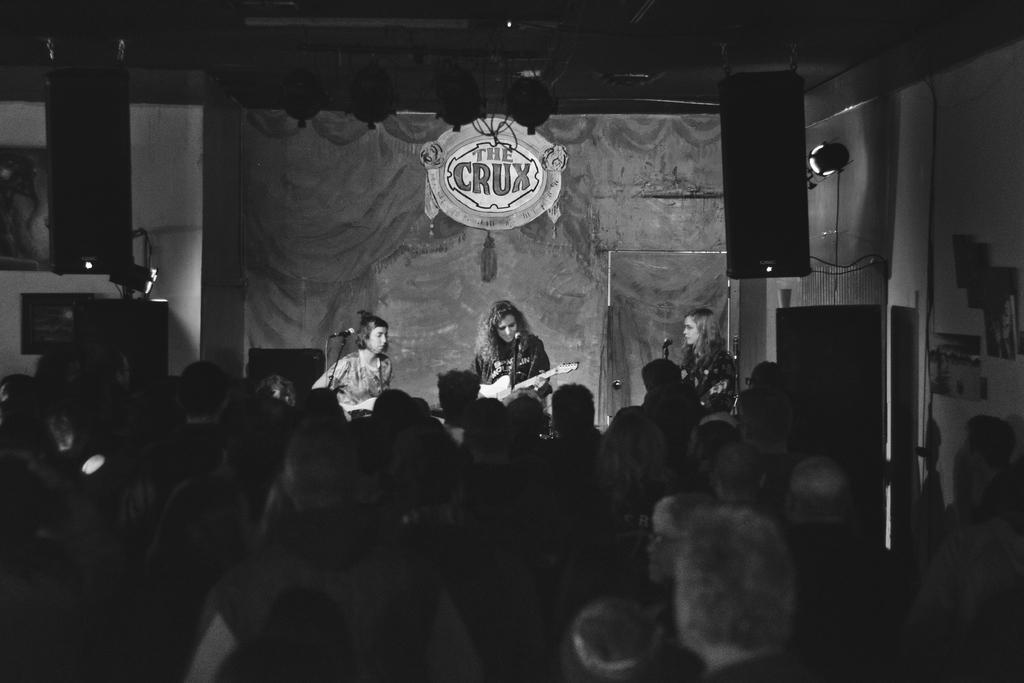Could you give a brief overview of what you see in this image? In this image I can see number of people and in the background I can see one of them is holding a guitar. I can also see three mics, a board, number of lights and on the board I can see something is written. On the both sides of this image I can see number of frames on the wall and I can see this image is black and white in colour. 